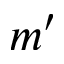<formula> <loc_0><loc_0><loc_500><loc_500>m ^ { \prime }</formula> 